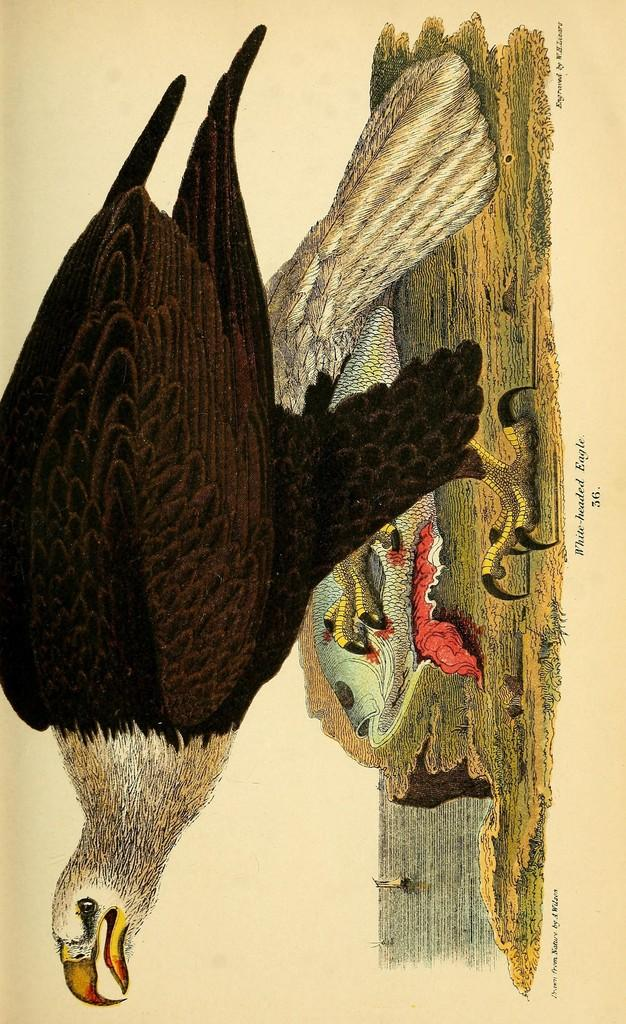What type of visual representation is the image? The image is a poster. What animals are depicted in the image? There is a bird and a fish in the image. What natural elements are present in the image? There is water and ground in the image. Where is the text located on the poster? The text is on the right side of the image. What type of creature can be seen climbing through the window in the image? There is no creature climbing through a window in the image; it only features a bird, a fish, water, and ground. 